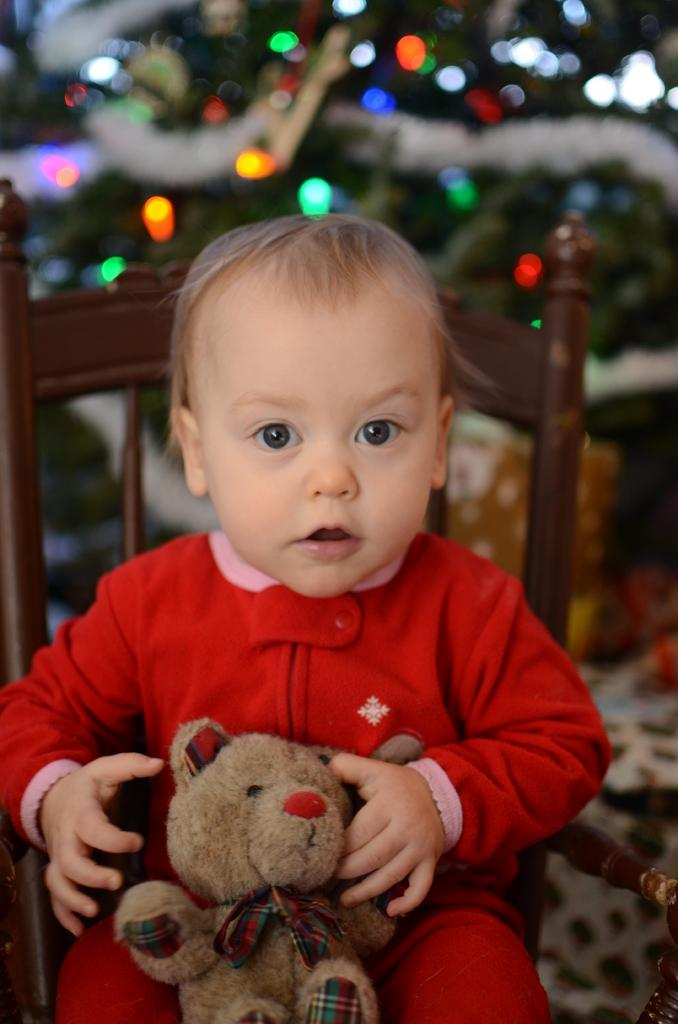What is the person in the image doing? The person is sitting on a chair in the image. What is the person holding while sitting on the chair? The person is holding a toy. What can be seen behind the person in the image? There are lights visible behind the person. How would you describe the background of the image? The background of the image is blurred. What type of bed can be seen in the image? There is no bed present in the image. What show is the person watching on the boat in the image? There is no show or boat present in the image. 